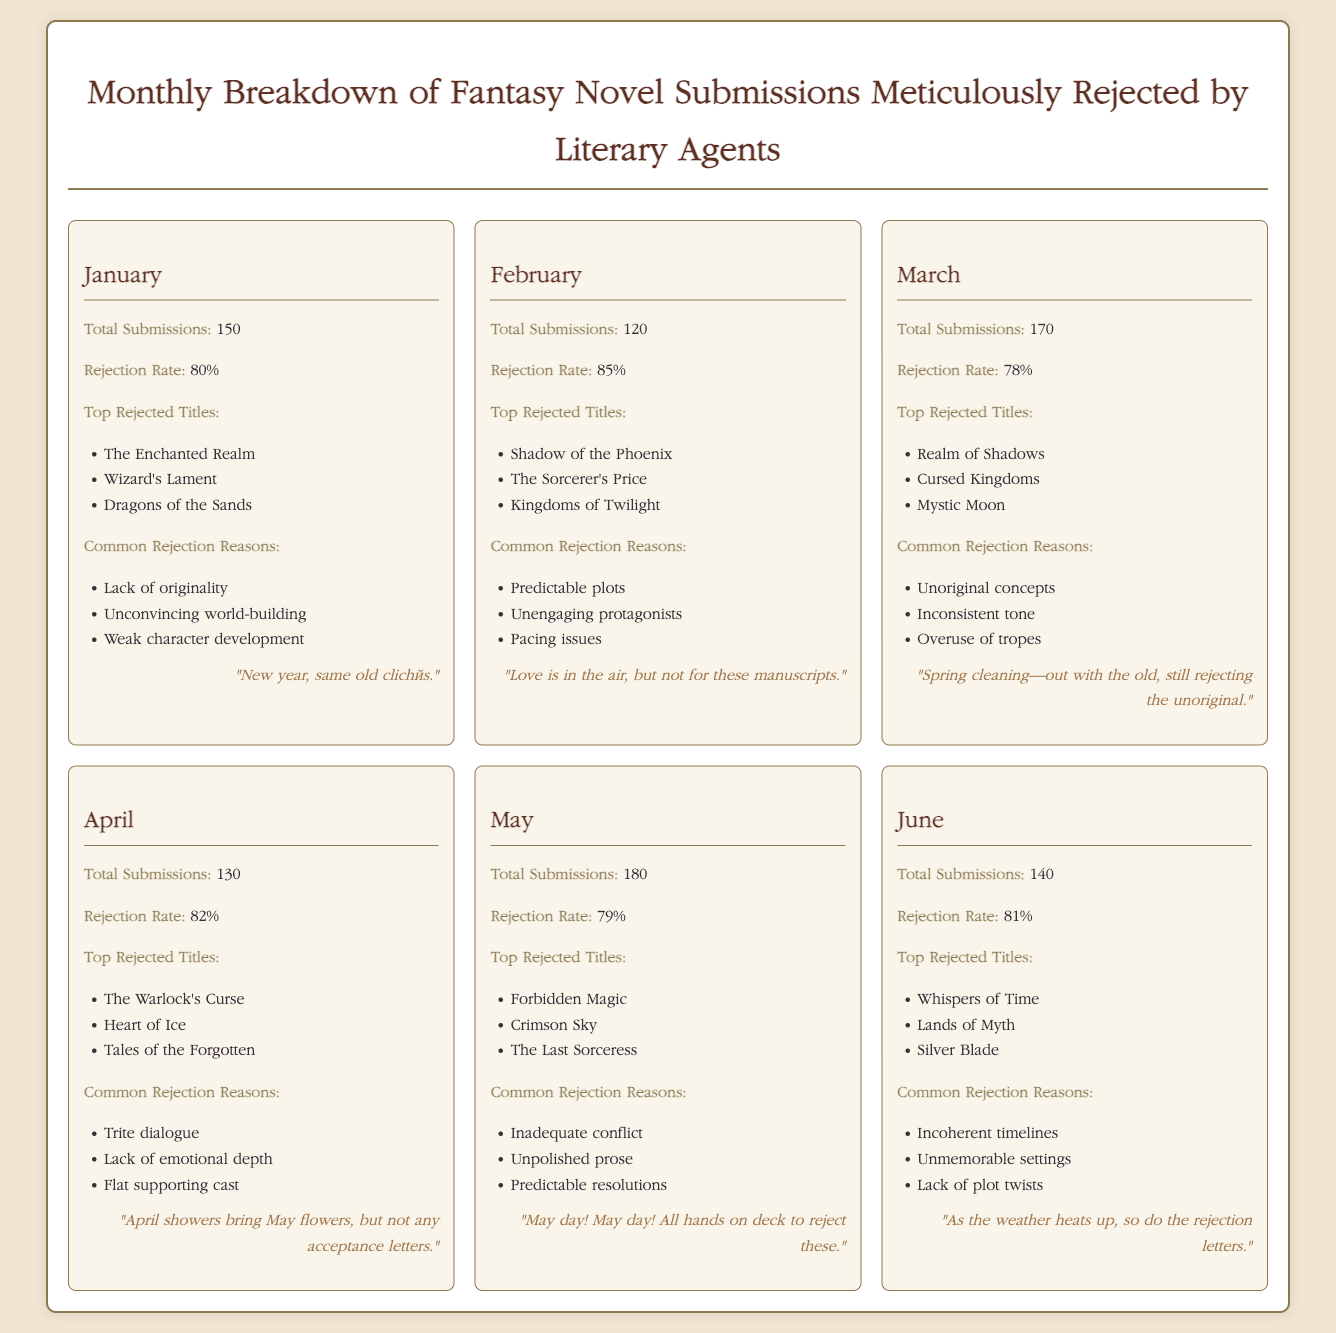What is the total number of submissions in January? The total number of submissions in January is explicitly stated in the document.
Answer: 150 What was the rejection rate in February? The rejection rate for February is identified in its corresponding section within the document.
Answer: 85% What are the top rejected titles in May? The document lists the top rejected titles for May, which can be directly referenced.
Answer: Forbidden Magic, Crimson Sky, The Last Sorceress Which month had the highest total submissions? By comparing the total submissions for each month, the month with the highest figure can be determined.
Answer: May What is a common rejection reason for submissions in April? The document provides a list of common rejection reasons, particularly for the month of April.
Answer: Trite dialogue How many submissions were there in June? The exact number of submissions in June is specified in the data presented.
Answer: 140 Which month had the lowest rejection rate? By evaluating the rejection rates across all months, the month with the lowest rate can be identified.
Answer: March What ironic observation is made for January? Each month includes an ironic observation, which can be directly cited from the document.
Answer: "New year, same old clichés." 